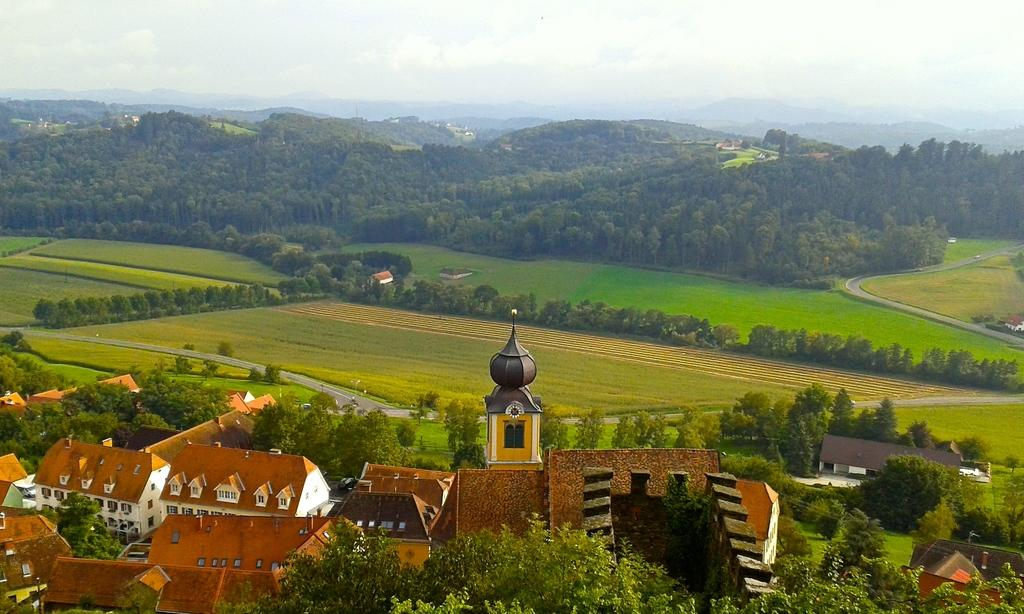What type of structures can be seen in the image? There are houses and a clock tower in the image. Where is the clock tower located in the image? The clock tower is at the bottom side of the image. What can be observed in the surroundings of the structures in the image? There is greenery around the area of the image. What color is the plate on the uncle's head in the image? There is no plate or uncle present in the image. 